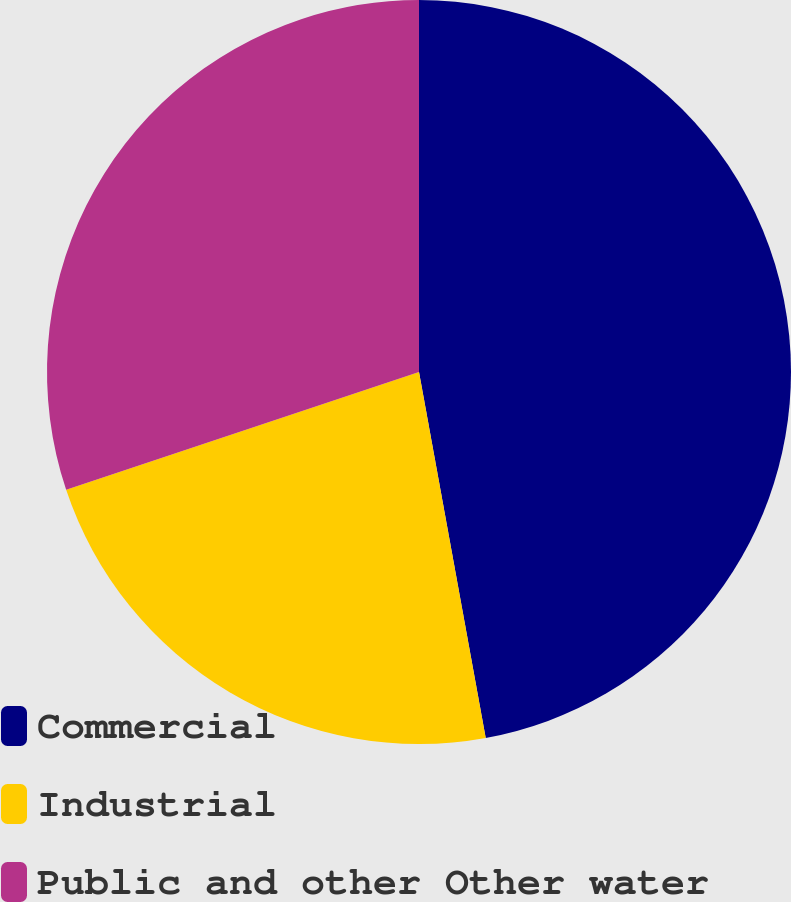<chart> <loc_0><loc_0><loc_500><loc_500><pie_chart><fcel>Commercial<fcel>Industrial<fcel>Public and other Other water<nl><fcel>47.13%<fcel>22.74%<fcel>30.13%<nl></chart> 